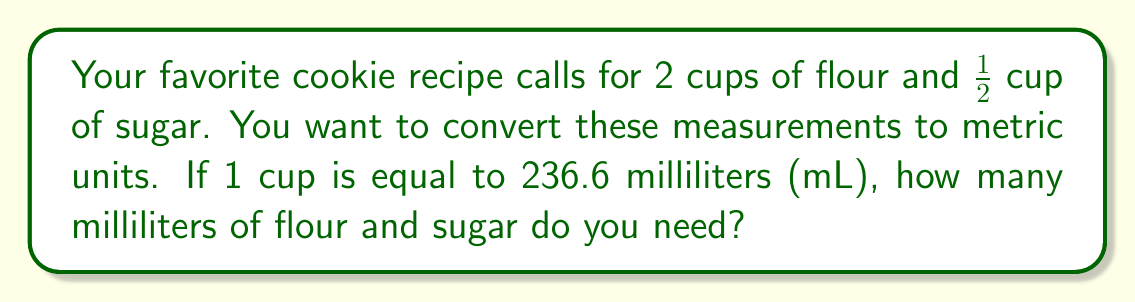Can you solve this math problem? Let's break this down step-by-step:

1. Convert flour measurement:
   - We need 2 cups of flour
   - 1 cup = 236.6 mL
   - So, 2 cups = $2 \times 236.6$ mL
   $$2 \times 236.6 = 473.2 \text{ mL}$$

2. Convert sugar measurement:
   - We need 1/2 cup of sugar
   - 1 cup = 236.6 mL
   - So, 1/2 cup = $\frac{1}{2} \times 236.6$ mL
   $$\frac{1}{2} \times 236.6 = 118.3 \text{ mL}$$

Therefore, you need 473.2 mL of flour and 118.3 mL of sugar.
Answer: Flour: 473.2 mL
Sugar: 118.3 mL 